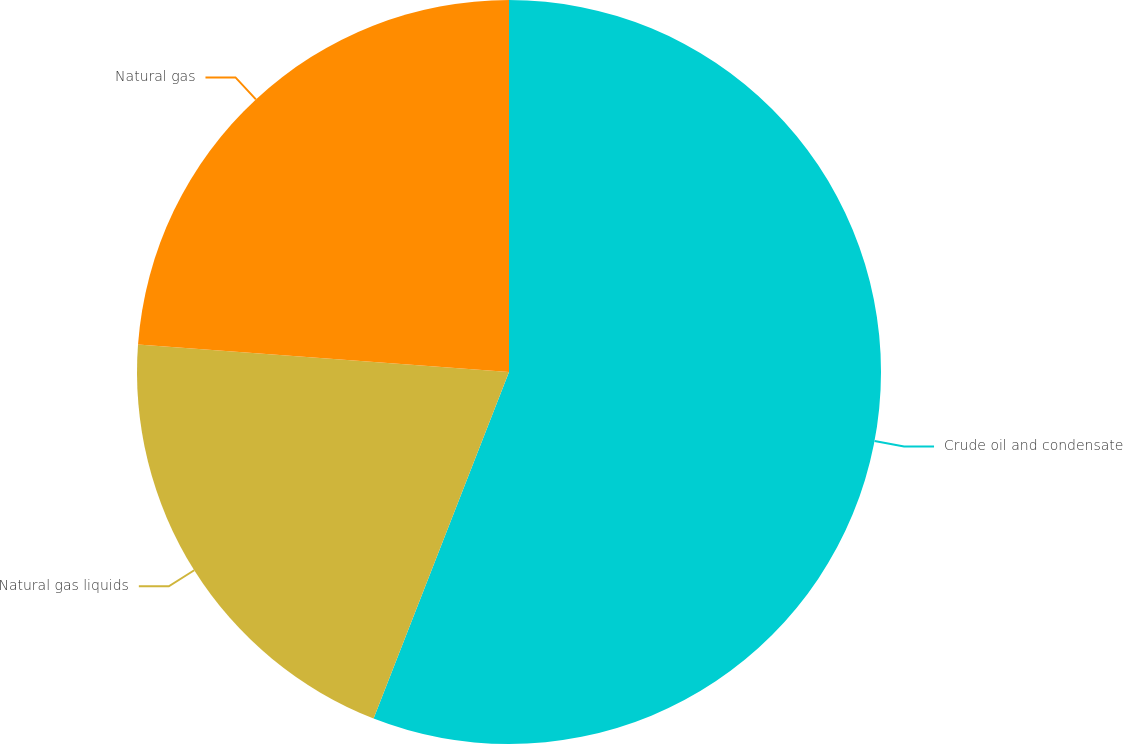<chart> <loc_0><loc_0><loc_500><loc_500><pie_chart><fcel>Crude oil and condensate<fcel>Natural gas liquids<fcel>Natural gas<nl><fcel>55.93%<fcel>20.25%<fcel>23.82%<nl></chart> 